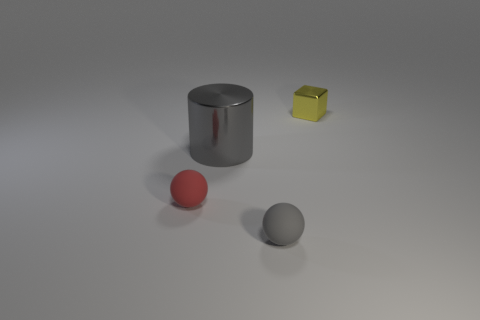Add 2 large red metal objects. How many objects exist? 6 Subtract all cylinders. How many objects are left? 3 Add 1 balls. How many balls exist? 3 Subtract 0 purple cubes. How many objects are left? 4 Subtract all tiny metal cubes. Subtract all small red balls. How many objects are left? 2 Add 1 large gray shiny things. How many large gray shiny things are left? 2 